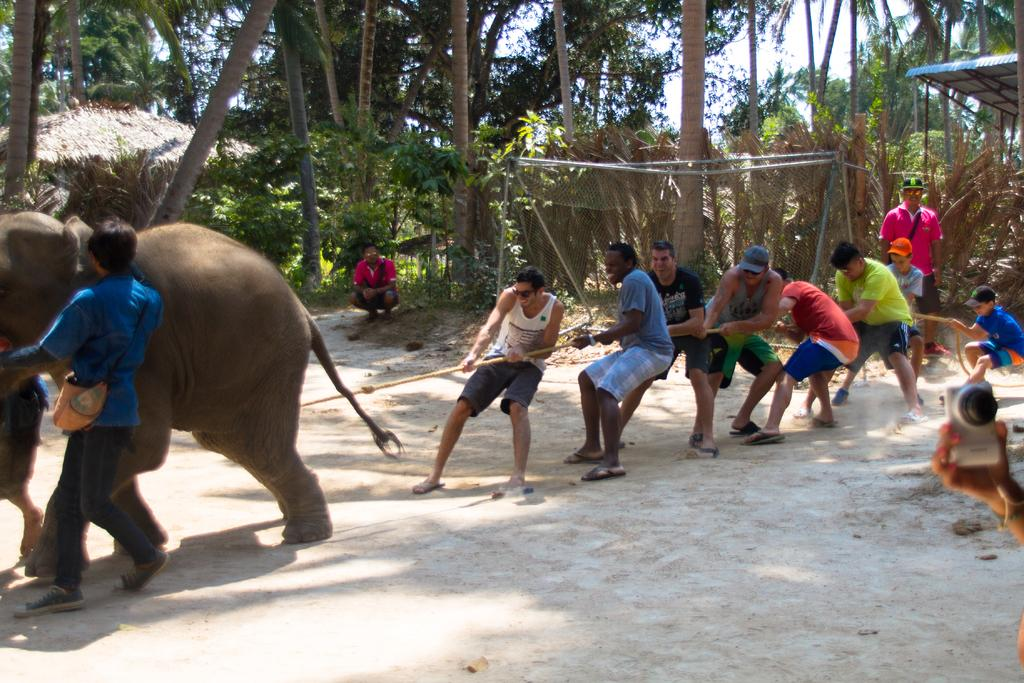What are the people in the image doing? The people in the image are holding a rope. Can you describe the activity involving an elephant in the image? There is a person holding an elephant on the left side of the image. What type of vegetation can be seen in the background of the image? There are green color trees in the background of the image. How many birds are sitting on the receipt in the image? There are no birds or receipts present in the image. Can you describe the arch in the image? There is no arch present in the image. 